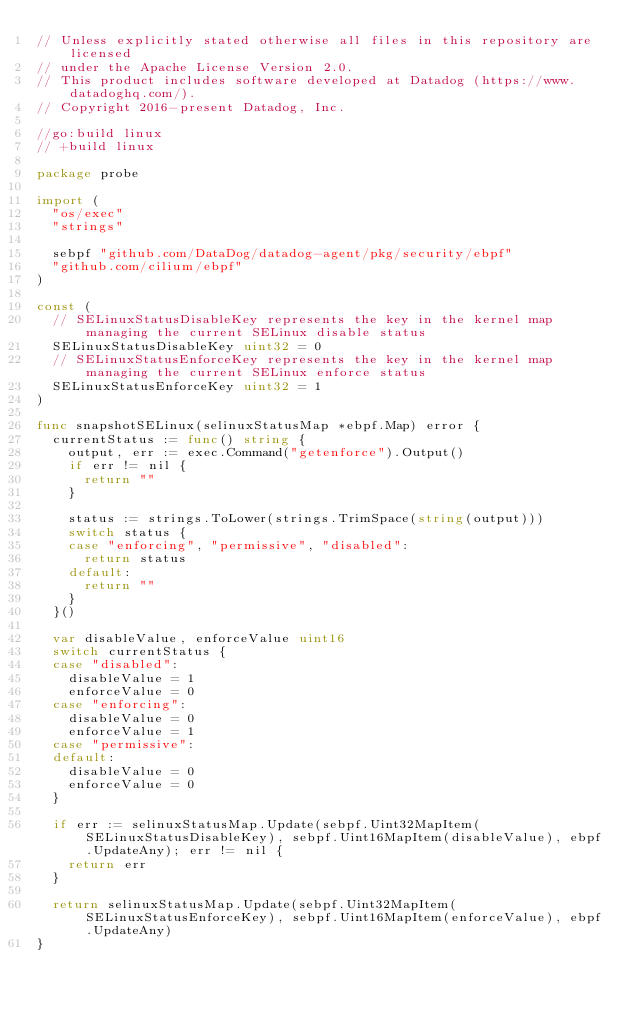<code> <loc_0><loc_0><loc_500><loc_500><_Go_>// Unless explicitly stated otherwise all files in this repository are licensed
// under the Apache License Version 2.0.
// This product includes software developed at Datadog (https://www.datadoghq.com/).
// Copyright 2016-present Datadog, Inc.

//go:build linux
// +build linux

package probe

import (
	"os/exec"
	"strings"

	sebpf "github.com/DataDog/datadog-agent/pkg/security/ebpf"
	"github.com/cilium/ebpf"
)

const (
	// SELinuxStatusDisableKey represents the key in the kernel map managing the current SELinux disable status
	SELinuxStatusDisableKey uint32 = 0
	// SELinuxStatusEnforceKey represents the key in the kernel map managing the current SELinux enforce status
	SELinuxStatusEnforceKey uint32 = 1
)

func snapshotSELinux(selinuxStatusMap *ebpf.Map) error {
	currentStatus := func() string {
		output, err := exec.Command("getenforce").Output()
		if err != nil {
			return ""
		}

		status := strings.ToLower(strings.TrimSpace(string(output)))
		switch status {
		case "enforcing", "permissive", "disabled":
			return status
		default:
			return ""
		}
	}()

	var disableValue, enforceValue uint16
	switch currentStatus {
	case "disabled":
		disableValue = 1
		enforceValue = 0
	case "enforcing":
		disableValue = 0
		enforceValue = 1
	case "permissive":
	default:
		disableValue = 0
		enforceValue = 0
	}

	if err := selinuxStatusMap.Update(sebpf.Uint32MapItem(SELinuxStatusDisableKey), sebpf.Uint16MapItem(disableValue), ebpf.UpdateAny); err != nil {
		return err
	}

	return selinuxStatusMap.Update(sebpf.Uint32MapItem(SELinuxStatusEnforceKey), sebpf.Uint16MapItem(enforceValue), ebpf.UpdateAny)
}
</code> 